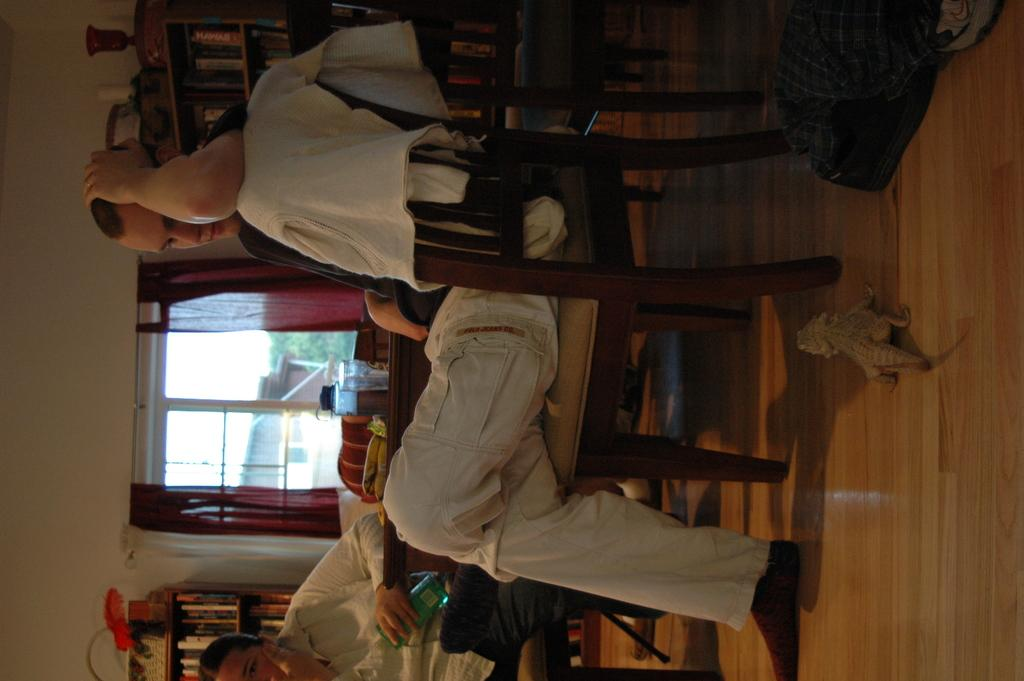What is the man in the image doing? The man is sitting on a chair in the image. Can you describe the other person in the image? There is another person at the bottom of the image. What can be seen on the left side of the image? There are windows on the left side of the image. What type of animal is on the right side of the image? There is an animal on the right side of the image. What is the plot of the image? There is no plot in the image, as it is a static image. --- Facts: 1. There is a person holding a book in the image. 2. The book is titled "The Art of War" by Sun Tzu. 3. The person is sitting on a couch. 4. There is a table next to the couch. 5. There is a cup of coffee on the table. Absurd Topics: elephant, piano, chessboard Conversation: What is the person in the image holding? The person in the image is holding a book. What is the title of the book the person is holding? The book is titled "The Art of War" by Sun Tzu. Where is the person sitting in the image? The person is sitting on a couch. What can be seen next to the couch in the image? There is a table next to the couch. What is on the table next to the couch in the image? There is a cup of coffee on the table. Reasoning: Let's think step by step in order to produce the conversation. We start by identifying the main subject in the image, which is the person holding a book. Then, we describe the specific details about the book, such as its title. Next, we observe the person's location in the image, which is sitting on a couch. After that, we describe the objects that are present in the image, such as the table and the cup of coffee on the table. We ensure that each question can be answered definitively with the information given. Absurd Question/Answer: Can you hear the elephant playing the piano in the image? There is no elephant or piano present in the image. --- Facts: 1. There is a group of people in the image. 2. The people are wearing traditional clothing. 3. The people are gathered around a bonfire. 4. There is a full moon in the sky. 5. The people are holding hands and dancing around the bonfire. Absurd Topics: basketball Conversation: How many people are in the image? There is a group of people in the image. What type of clothing are the people wearing in the image? The people are wearing traditional clothing. What are the people in the image doing? The people are gathered around a full moon bonfire. 